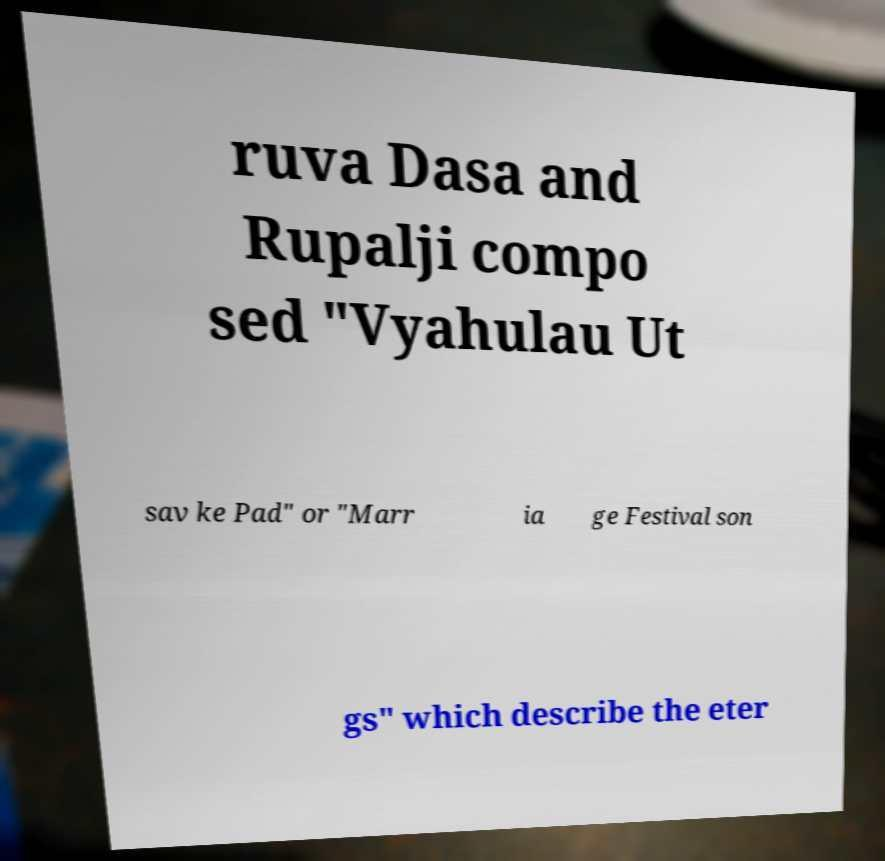Please identify and transcribe the text found in this image. ruva Dasa and Rupalji compo sed "Vyahulau Ut sav ke Pad" or "Marr ia ge Festival son gs" which describe the eter 